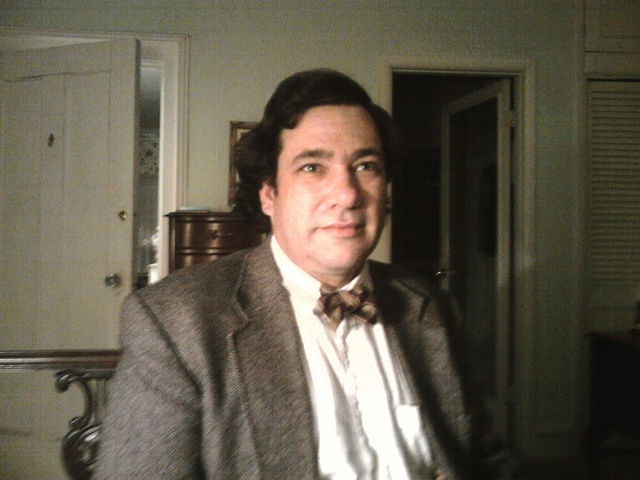Describe the objects in this image and their specific colors. I can see people in gray, black, and white tones and tie in gray, black, and maroon tones in this image. 